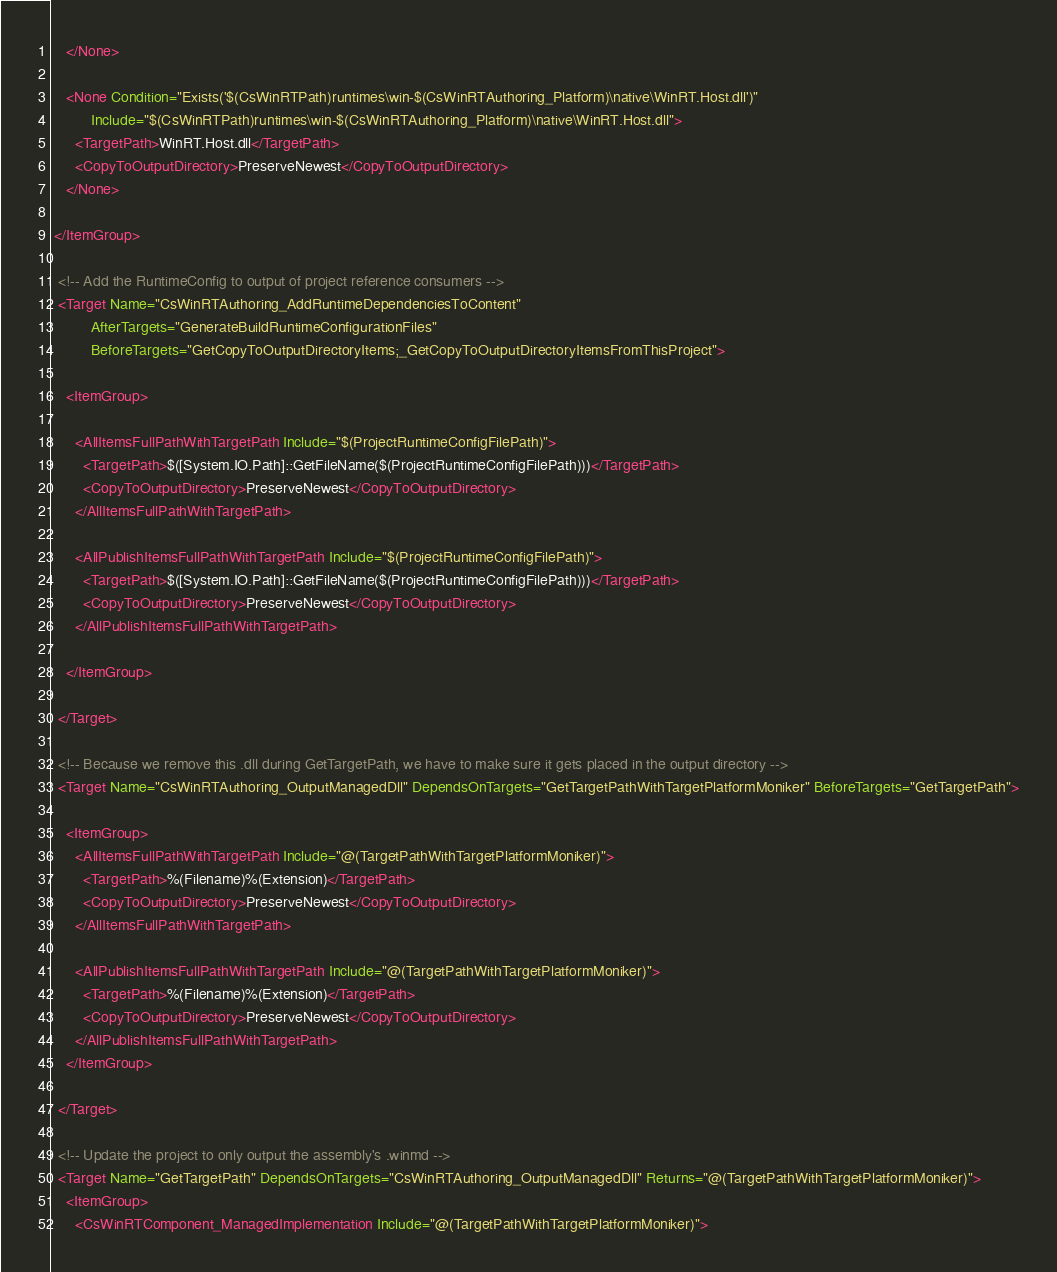Convert code to text. <code><loc_0><loc_0><loc_500><loc_500><_XML_>    </None>

    <None Condition="Exists('$(CsWinRTPath)runtimes\win-$(CsWinRTAuthoring_Platform)\native\WinRT.Host.dll')" 
          Include="$(CsWinRTPath)runtimes\win-$(CsWinRTAuthoring_Platform)\native\WinRT.Host.dll">
      <TargetPath>WinRT.Host.dll</TargetPath>
      <CopyToOutputDirectory>PreserveNewest</CopyToOutputDirectory>
    </None>

 </ItemGroup>

  <!-- Add the RuntimeConfig to output of project reference consumers -->
  <Target Name="CsWinRTAuthoring_AddRuntimeDependenciesToContent" 
          AfterTargets="GenerateBuildRuntimeConfigurationFiles" 
          BeforeTargets="GetCopyToOutputDirectoryItems;_GetCopyToOutputDirectoryItemsFromThisProject">

    <ItemGroup>

      <AllItemsFullPathWithTargetPath Include="$(ProjectRuntimeConfigFilePath)">
        <TargetPath>$([System.IO.Path]::GetFileName($(ProjectRuntimeConfigFilePath)))</TargetPath>
        <CopyToOutputDirectory>PreserveNewest</CopyToOutputDirectory>
      </AllItemsFullPathWithTargetPath>

      <AllPublishItemsFullPathWithTargetPath Include="$(ProjectRuntimeConfigFilePath)">
        <TargetPath>$([System.IO.Path]::GetFileName($(ProjectRuntimeConfigFilePath)))</TargetPath>
        <CopyToOutputDirectory>PreserveNewest</CopyToOutputDirectory>
      </AllPublishItemsFullPathWithTargetPath>
    
    </ItemGroup>
  
  </Target>

  <!-- Because we remove this .dll during GetTargetPath, we have to make sure it gets placed in the output directory -->
  <Target Name="CsWinRTAuthoring_OutputManagedDll" DependsOnTargets="GetTargetPathWithTargetPlatformMoniker" BeforeTargets="GetTargetPath">
    
    <ItemGroup> 
      <AllItemsFullPathWithTargetPath Include="@(TargetPathWithTargetPlatformMoniker)">
        <TargetPath>%(Filename)%(Extension)</TargetPath>
        <CopyToOutputDirectory>PreserveNewest</CopyToOutputDirectory>
      </AllItemsFullPathWithTargetPath>

      <AllPublishItemsFullPathWithTargetPath Include="@(TargetPathWithTargetPlatformMoniker)">
        <TargetPath>%(Filename)%(Extension)</TargetPath>
        <CopyToOutputDirectory>PreserveNewest</CopyToOutputDirectory> 
      </AllPublishItemsFullPathWithTargetPath>
    </ItemGroup>

  </Target>

  <!-- Update the project to only output the assembly's .winmd -->
  <Target Name="GetTargetPath" DependsOnTargets="CsWinRTAuthoring_OutputManagedDll" Returns="@(TargetPathWithTargetPlatformMoniker)">
    <ItemGroup>
      <CsWinRTComponent_ManagedImplementation Include="@(TargetPathWithTargetPlatformMoniker)"></code> 